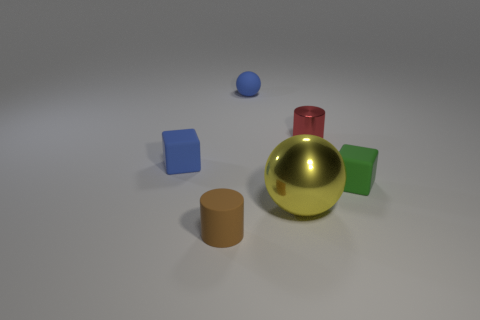Add 2 tiny red metallic things. How many objects exist? 8 Subtract all cylinders. How many objects are left? 4 Subtract 1 cylinders. How many cylinders are left? 1 Subtract all red cubes. Subtract all purple cylinders. How many cubes are left? 2 Subtract all tiny blue rubber spheres. Subtract all yellow spheres. How many objects are left? 4 Add 6 red metallic objects. How many red metallic objects are left? 7 Add 2 rubber balls. How many rubber balls exist? 3 Subtract 0 cyan cubes. How many objects are left? 6 